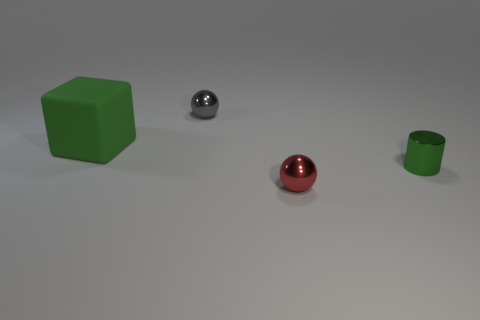Add 3 green cubes. How many objects exist? 7 Subtract all cylinders. How many objects are left? 3 Add 4 big green matte objects. How many big green matte objects are left? 5 Add 1 green blocks. How many green blocks exist? 2 Subtract 0 cyan blocks. How many objects are left? 4 Subtract all small green objects. Subtract all small spheres. How many objects are left? 1 